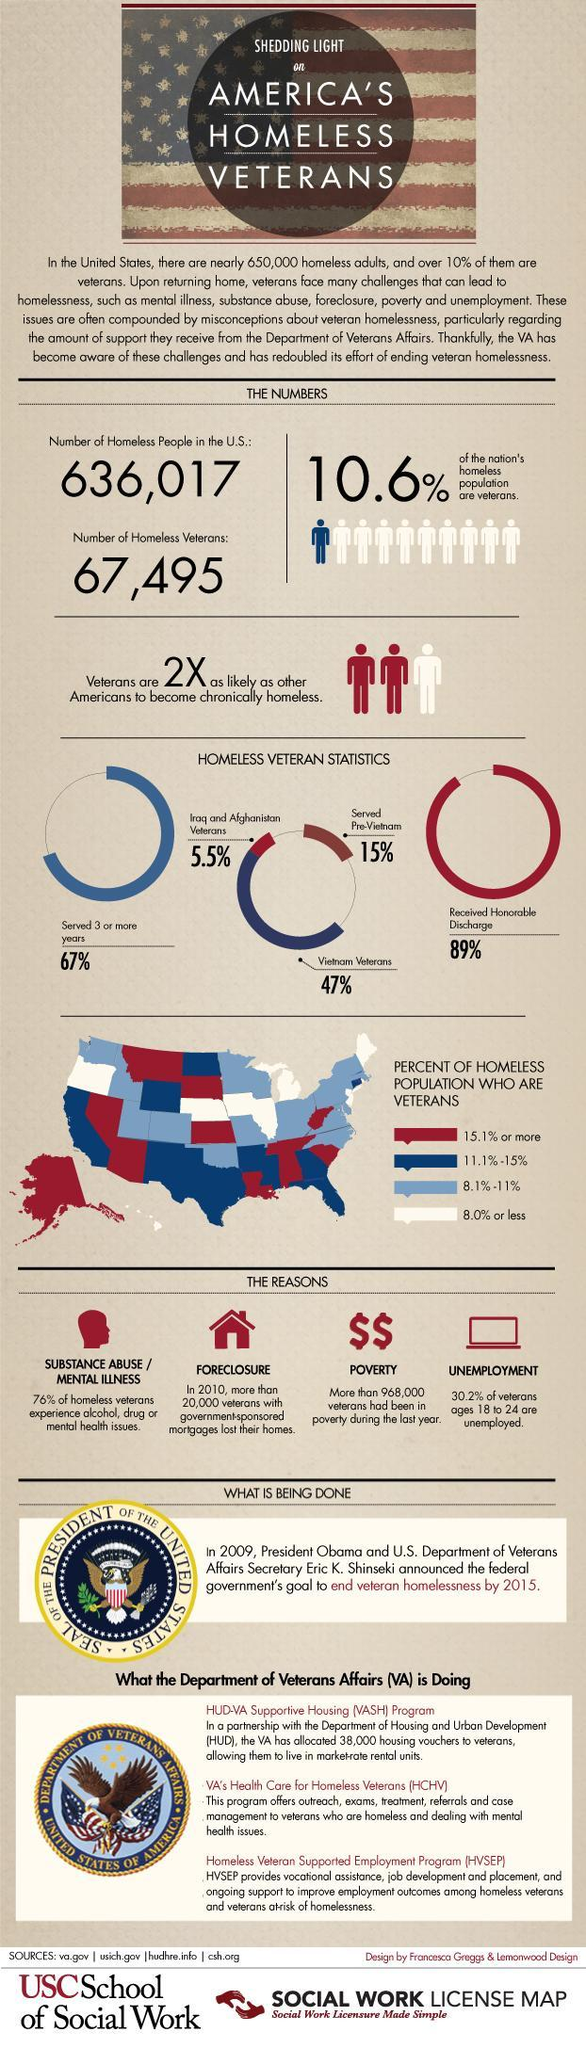What percentage of veterans face mental issues or substance abuse?
Answer the question with a short phrase. 76% What is the rate of unemployment among young veterans? 30.2% In the map, which color is used to mark the states with less than 8% homeless veterans - red, white or blue? white 